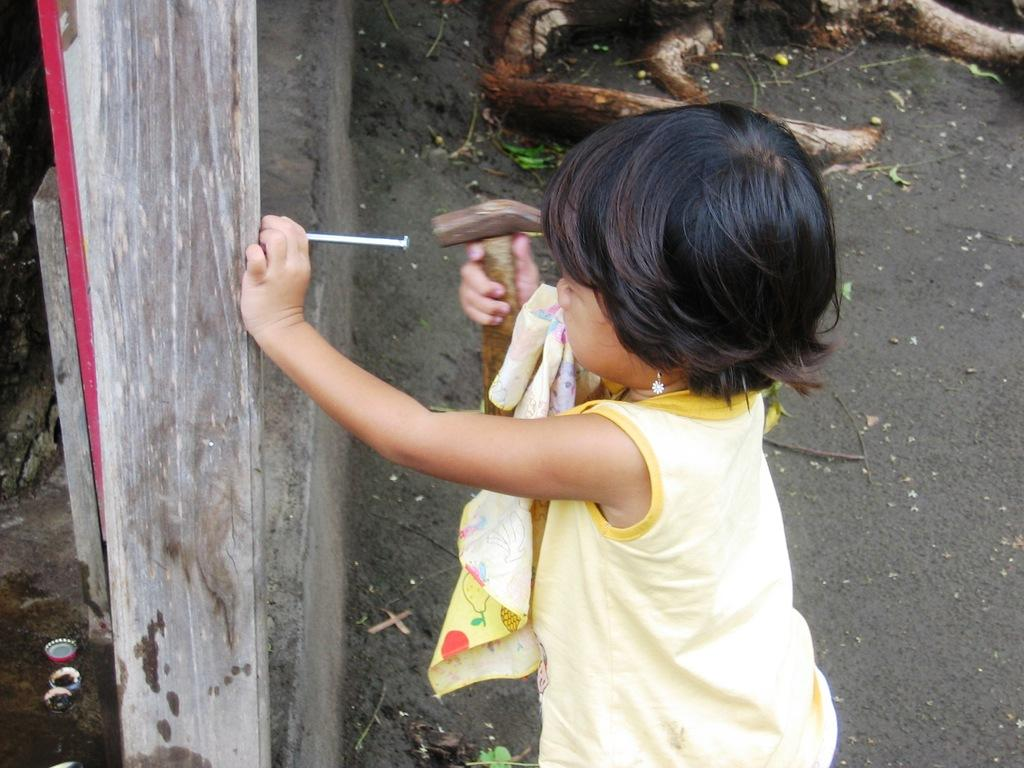Who is the main subject in the image? There is a girl in the image. What is the girl doing in the image? The girl is standing on the ground and holding a hammer in one hand and a nail in the other hand. What is in front of the girl? There is a wall in front of the girl. Can you tell me what type of airplane the girl is flying in the image? There is no airplane present in the image; the girl is standing on the ground holding a hammer and a nail. Who is the creator of the wall in the image? The facts provided do not give any information about the creator of the wall. 